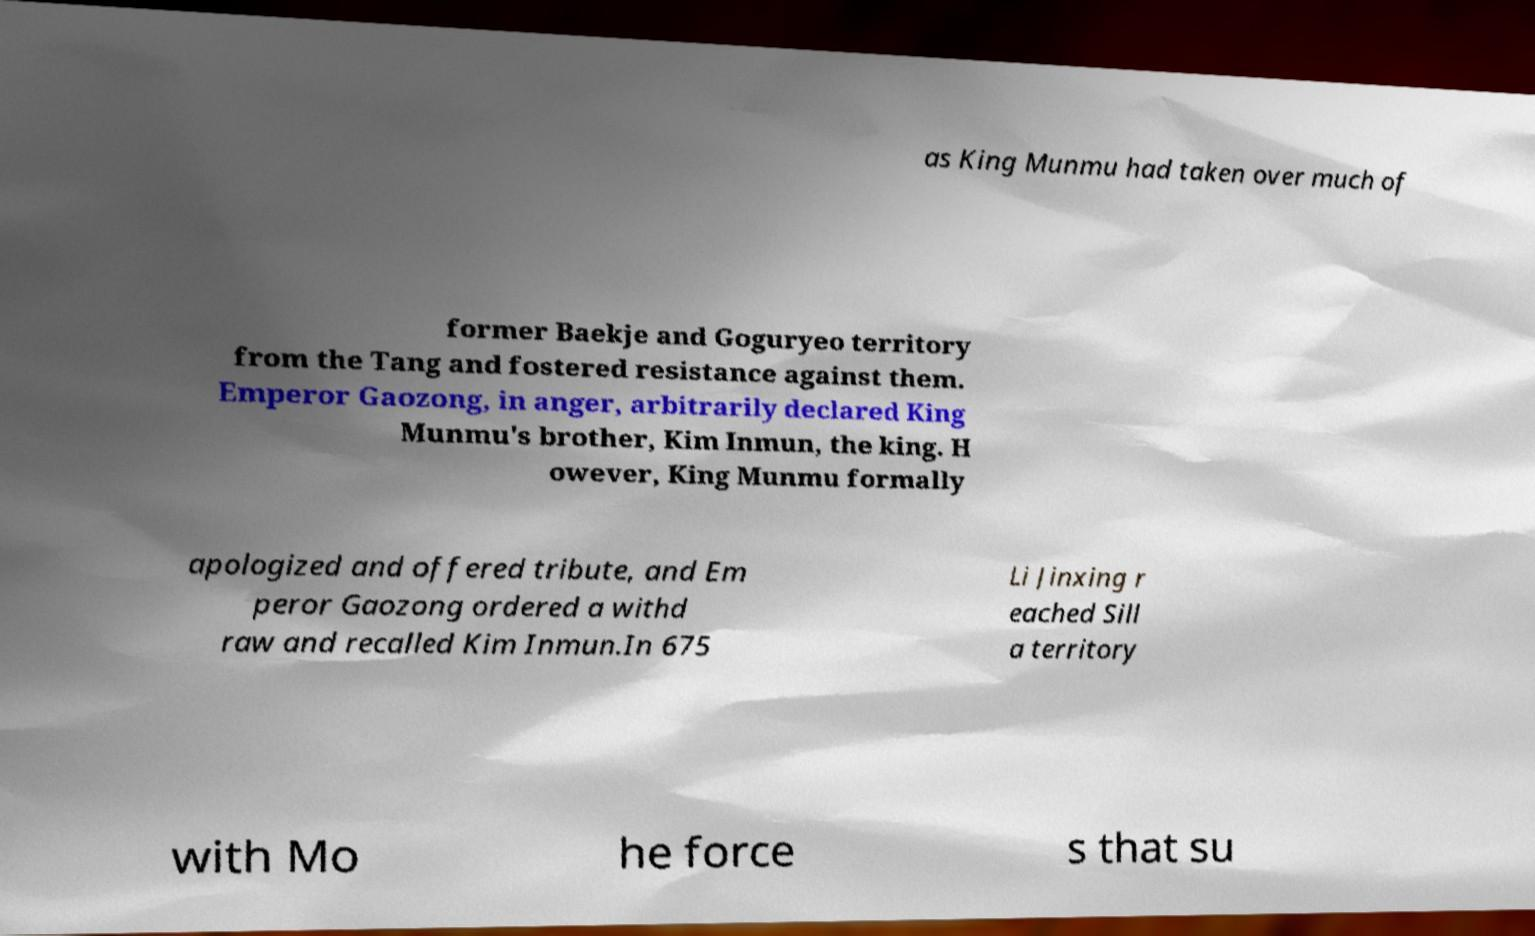Can you read and provide the text displayed in the image?This photo seems to have some interesting text. Can you extract and type it out for me? as King Munmu had taken over much of former Baekje and Goguryeo territory from the Tang and fostered resistance against them. Emperor Gaozong, in anger, arbitrarily declared King Munmu's brother, Kim Inmun, the king. H owever, King Munmu formally apologized and offered tribute, and Em peror Gaozong ordered a withd raw and recalled Kim Inmun.In 675 Li Jinxing r eached Sill a territory with Mo he force s that su 